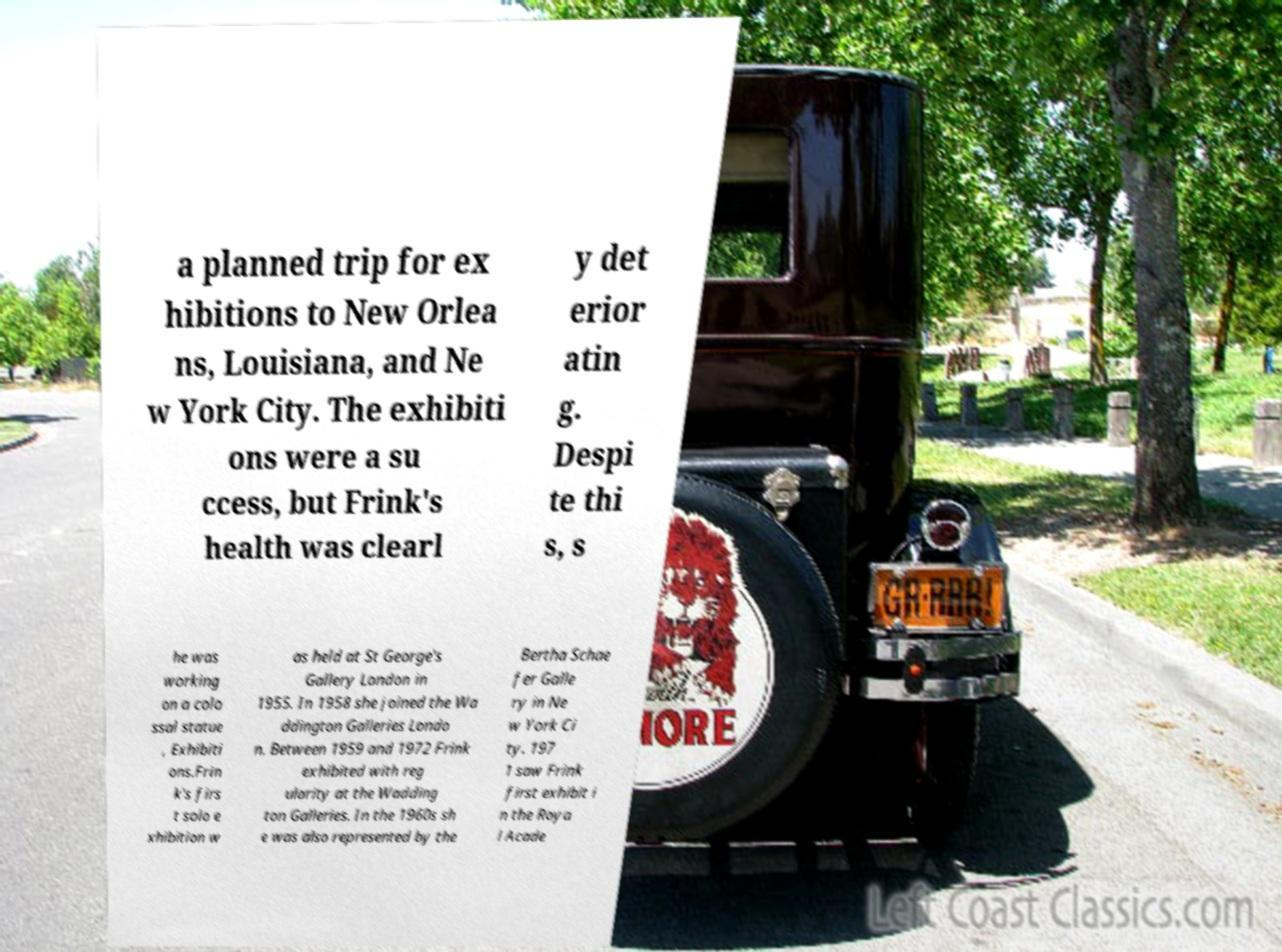There's text embedded in this image that I need extracted. Can you transcribe it verbatim? a planned trip for ex hibitions to New Orlea ns, Louisiana, and Ne w York City. The exhibiti ons were a su ccess, but Frink's health was clearl y det erior atin g. Despi te thi s, s he was working on a colo ssal statue , Exhibiti ons.Frin k's firs t solo e xhibition w as held at St George's Gallery London in 1955. In 1958 she joined the Wa ddington Galleries Londo n. Between 1959 and 1972 Frink exhibited with reg ularity at the Wadding ton Galleries. In the 1960s sh e was also represented by the Bertha Schae fer Galle ry in Ne w York Ci ty. 197 1 saw Frink first exhibit i n the Roya l Acade 